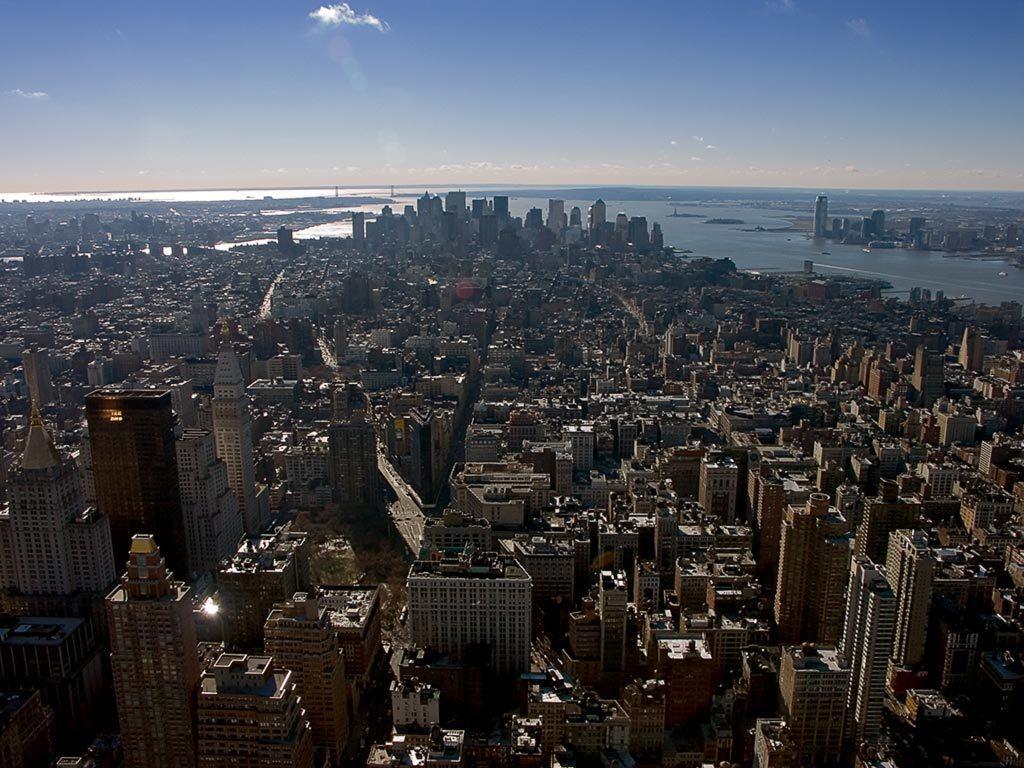How would you summarize this image in a sentence or two? In this image I can see number of buildings, the road and few vehicles on the road. In the background I can see the water, few buildings and the sky. 